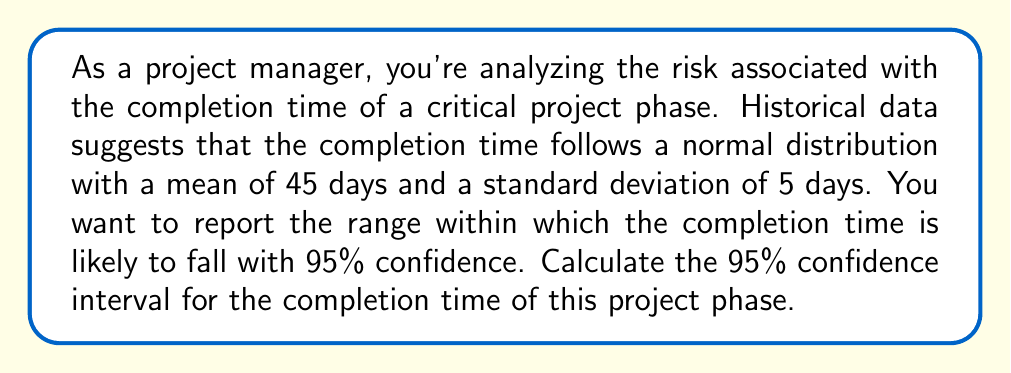Give your solution to this math problem. To calculate the 95% confidence interval for the completion time, we'll follow these steps:

1. Identify the given information:
   - Mean (μ) = 45 days
   - Standard deviation (σ) = 5 days
   - Confidence level = 95%

2. Determine the z-score for a 95% confidence interval:
   The z-score for a 95% confidence interval is 1.96 (from standard normal distribution tables).

3. Calculate the margin of error:
   Margin of error = z-score × (σ / √n)
   Since we're dealing with a population parameter, n = 1
   Margin of error = 1.96 × (5 / √1) = 1.96 × 5 = 9.8 days

4. Calculate the confidence interval:
   Lower bound = μ - margin of error
   Upper bound = μ + margin of error

   Lower bound = 45 - 9.8 = 35.2 days
   Upper bound = 45 + 9.8 = 54.8 days

5. Round the results to one decimal place:
   95% Confidence Interval: (35.2 days, 54.8 days)

The interpretation of this result is that we can be 95% confident that the true completion time for this project phase will fall between 35.2 and 54.8 days.
Answer: (35.2 days, 54.8 days) 